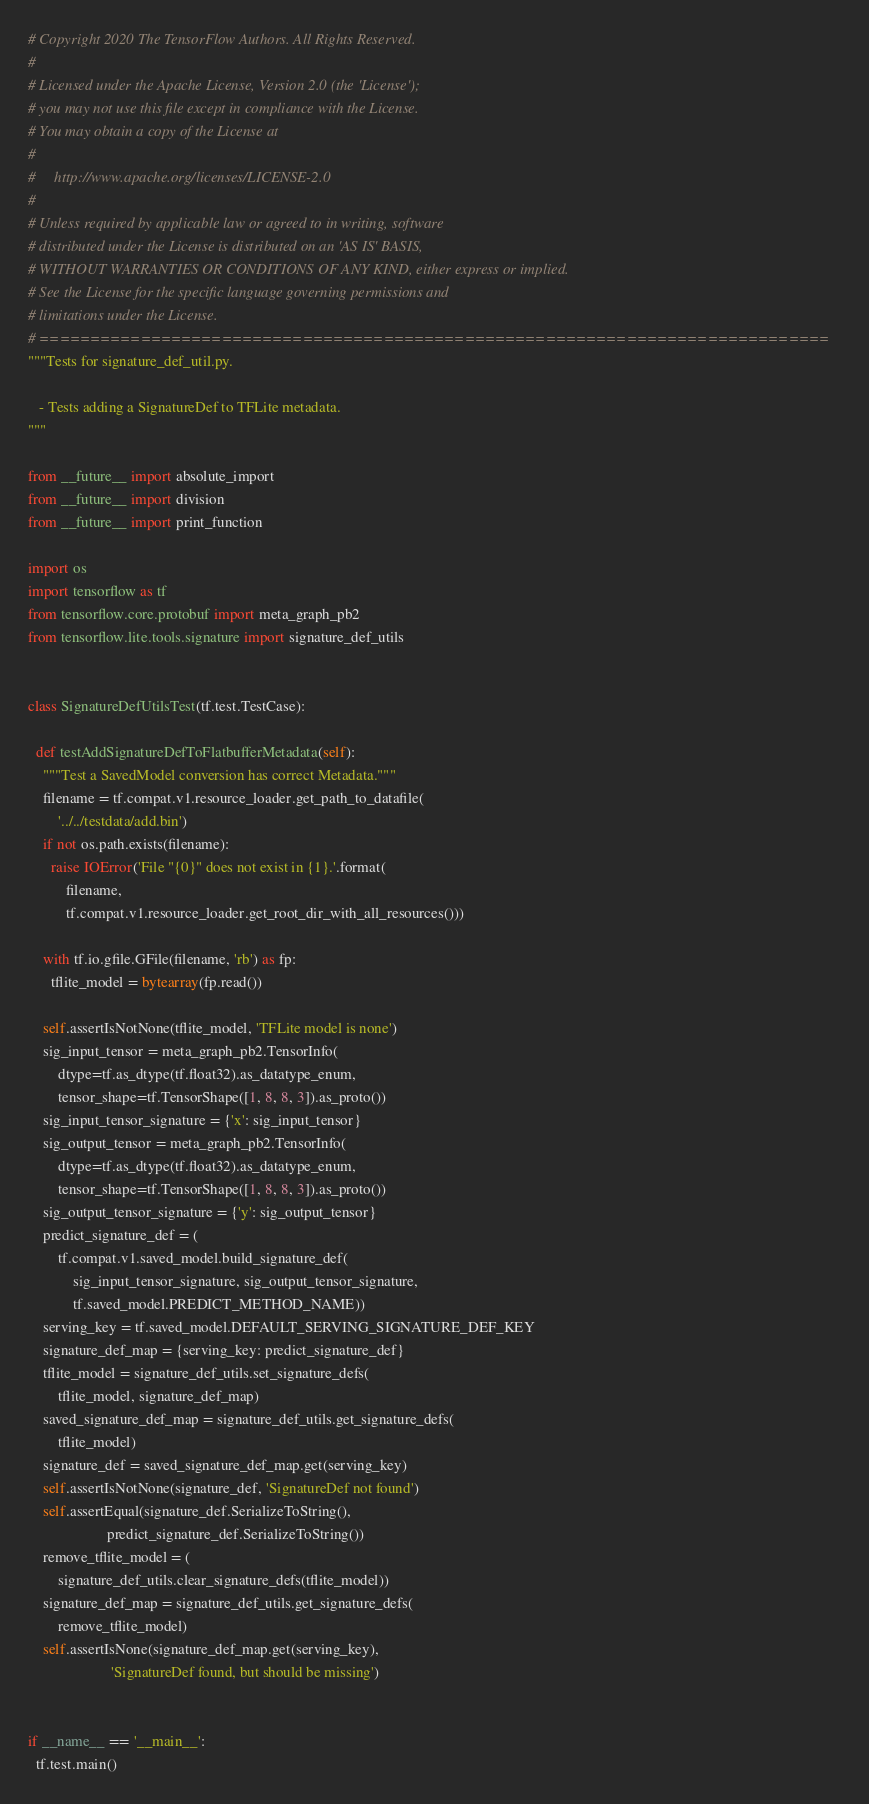<code> <loc_0><loc_0><loc_500><loc_500><_Python_># Copyright 2020 The TensorFlow Authors. All Rights Reserved.
#
# Licensed under the Apache License, Version 2.0 (the 'License');
# you may not use this file except in compliance with the License.
# You may obtain a copy of the License at
#
#     http://www.apache.org/licenses/LICENSE-2.0
#
# Unless required by applicable law or agreed to in writing, software
# distributed under the License is distributed on an 'AS IS' BASIS,
# WITHOUT WARRANTIES OR CONDITIONS OF ANY KIND, either express or implied.
# See the License for the specific language governing permissions and
# limitations under the License.
# ==============================================================================
"""Tests for signature_def_util.py.

   - Tests adding a SignatureDef to TFLite metadata.
"""

from __future__ import absolute_import
from __future__ import division
from __future__ import print_function

import os
import tensorflow as tf
from tensorflow.core.protobuf import meta_graph_pb2
from tensorflow.lite.tools.signature import signature_def_utils


class SignatureDefUtilsTest(tf.test.TestCase):

  def testAddSignatureDefToFlatbufferMetadata(self):
    """Test a SavedModel conversion has correct Metadata."""
    filename = tf.compat.v1.resource_loader.get_path_to_datafile(
        '../../testdata/add.bin')
    if not os.path.exists(filename):
      raise IOError('File "{0}" does not exist in {1}.'.format(
          filename,
          tf.compat.v1.resource_loader.get_root_dir_with_all_resources()))

    with tf.io.gfile.GFile(filename, 'rb') as fp:
      tflite_model = bytearray(fp.read())

    self.assertIsNotNone(tflite_model, 'TFLite model is none')
    sig_input_tensor = meta_graph_pb2.TensorInfo(
        dtype=tf.as_dtype(tf.float32).as_datatype_enum,
        tensor_shape=tf.TensorShape([1, 8, 8, 3]).as_proto())
    sig_input_tensor_signature = {'x': sig_input_tensor}
    sig_output_tensor = meta_graph_pb2.TensorInfo(
        dtype=tf.as_dtype(tf.float32).as_datatype_enum,
        tensor_shape=tf.TensorShape([1, 8, 8, 3]).as_proto())
    sig_output_tensor_signature = {'y': sig_output_tensor}
    predict_signature_def = (
        tf.compat.v1.saved_model.build_signature_def(
            sig_input_tensor_signature, sig_output_tensor_signature,
            tf.saved_model.PREDICT_METHOD_NAME))
    serving_key = tf.saved_model.DEFAULT_SERVING_SIGNATURE_DEF_KEY
    signature_def_map = {serving_key: predict_signature_def}
    tflite_model = signature_def_utils.set_signature_defs(
        tflite_model, signature_def_map)
    saved_signature_def_map = signature_def_utils.get_signature_defs(
        tflite_model)
    signature_def = saved_signature_def_map.get(serving_key)
    self.assertIsNotNone(signature_def, 'SignatureDef not found')
    self.assertEqual(signature_def.SerializeToString(),
                     predict_signature_def.SerializeToString())
    remove_tflite_model = (
        signature_def_utils.clear_signature_defs(tflite_model))
    signature_def_map = signature_def_utils.get_signature_defs(
        remove_tflite_model)
    self.assertIsNone(signature_def_map.get(serving_key),
                      'SignatureDef found, but should be missing')


if __name__ == '__main__':
  tf.test.main()
</code> 